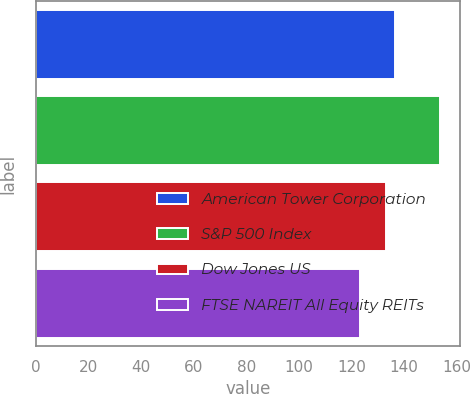Convert chart to OTSL. <chart><loc_0><loc_0><loc_500><loc_500><bar_chart><fcel>American Tower Corporation<fcel>S&P 500 Index<fcel>Dow Jones US<fcel>FTSE NAREIT All Equity REITs<nl><fcel>136.68<fcel>153.58<fcel>133.28<fcel>123.12<nl></chart> 